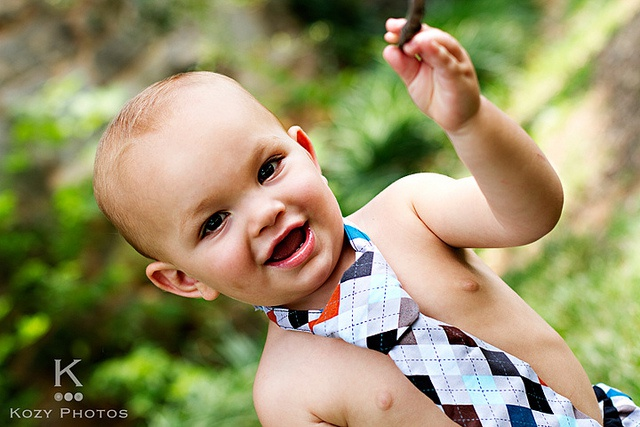Describe the objects in this image and their specific colors. I can see people in tan, lightgray, and salmon tones and tie in tan, lavender, black, lightblue, and darkgray tones in this image. 